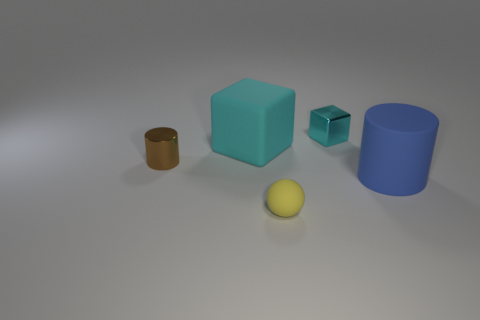Are there fewer tiny brown metal things than blue metal cubes?
Keep it short and to the point. No. How many rubber cylinders are the same size as the cyan metallic object?
Keep it short and to the point. 0. There is a rubber thing that is the same color as the small block; what is its shape?
Keep it short and to the point. Cube. What material is the big blue cylinder?
Ensure brevity in your answer.  Rubber. There is a rubber object left of the small yellow rubber sphere; what size is it?
Provide a succinct answer. Large. How many cyan metallic objects have the same shape as the brown metal object?
Ensure brevity in your answer.  0. There is a blue thing that is the same material as the large cyan block; what shape is it?
Ensure brevity in your answer.  Cylinder. How many cyan things are rubber cubes or tiny metal blocks?
Provide a short and direct response. 2. There is a large cyan matte thing; are there any tiny cyan cubes in front of it?
Offer a very short reply. No. There is a rubber object that is behind the big blue rubber cylinder; is it the same shape as the cyan object that is on the right side of the large block?
Your answer should be compact. Yes. 